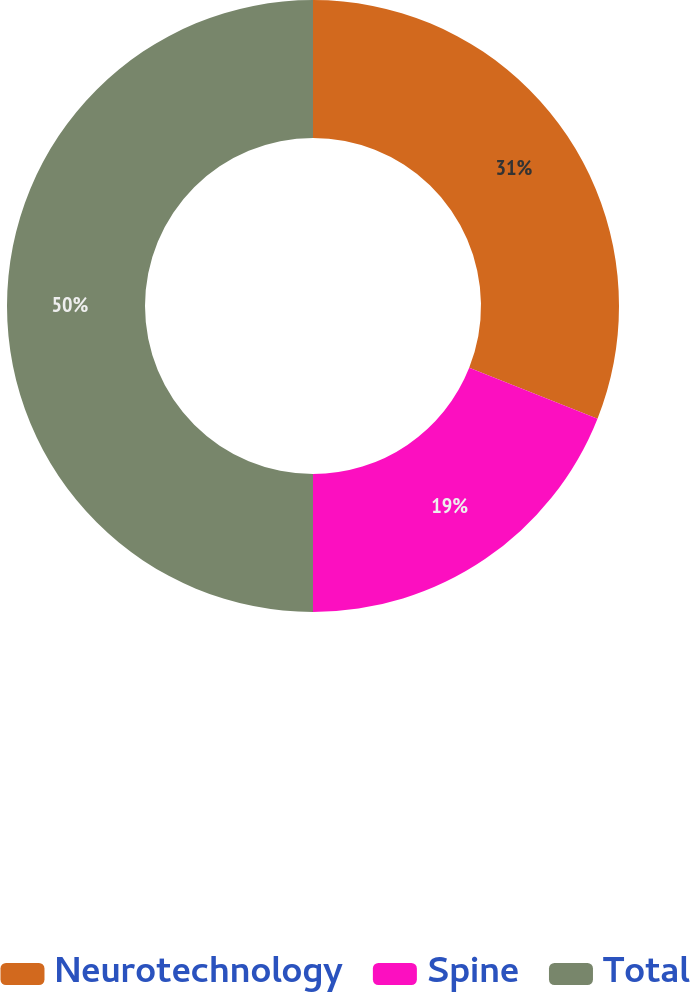Convert chart. <chart><loc_0><loc_0><loc_500><loc_500><pie_chart><fcel>Neurotechnology<fcel>Spine<fcel>Total<nl><fcel>31.0%<fcel>19.0%<fcel>50.0%<nl></chart> 